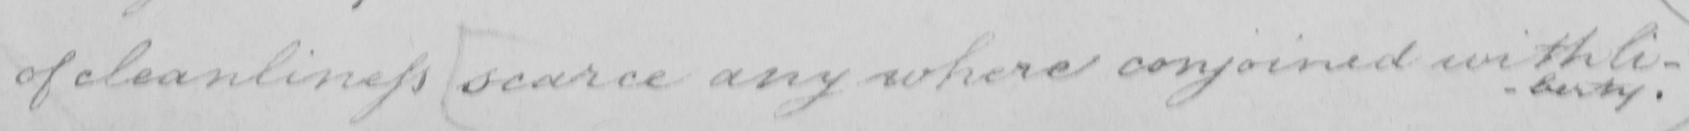Please provide the text content of this handwritten line. of cleanliness  [ scarce any where conjoined with li- 